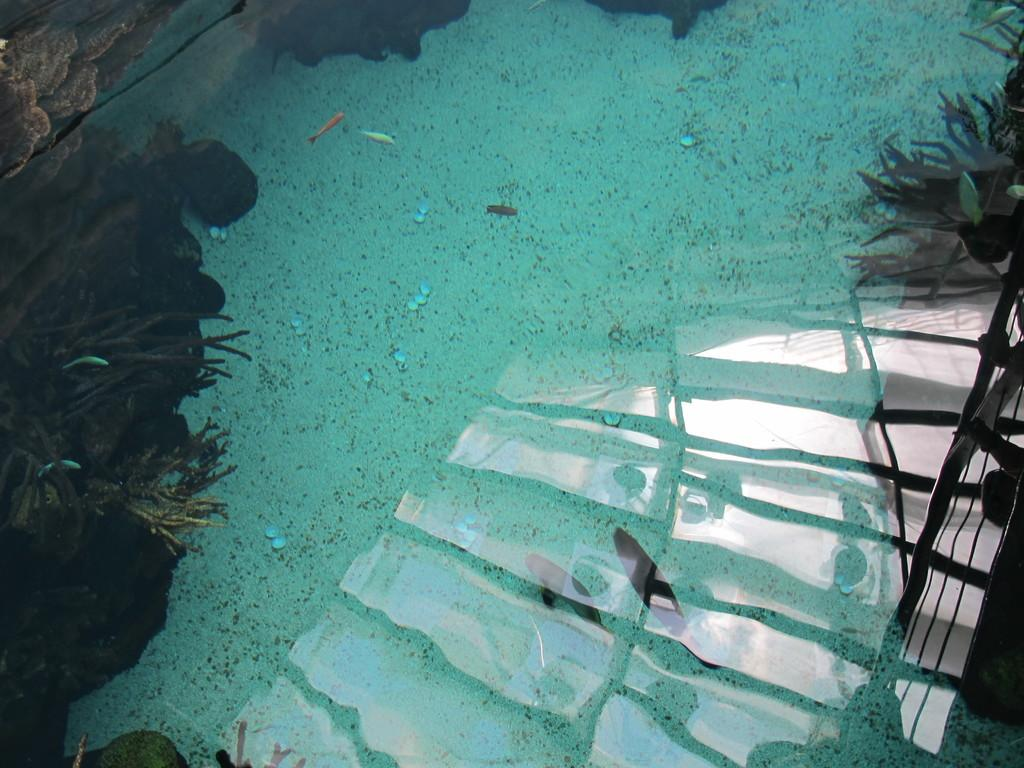What is the main feature of the image? There is a pool with water in the image. What can be found in the pool? There are fishes and water plants in the pool. What type of fruit is floating in the pool? There is no fruit present in the image; it features a pool with water, fishes, and water plants. 